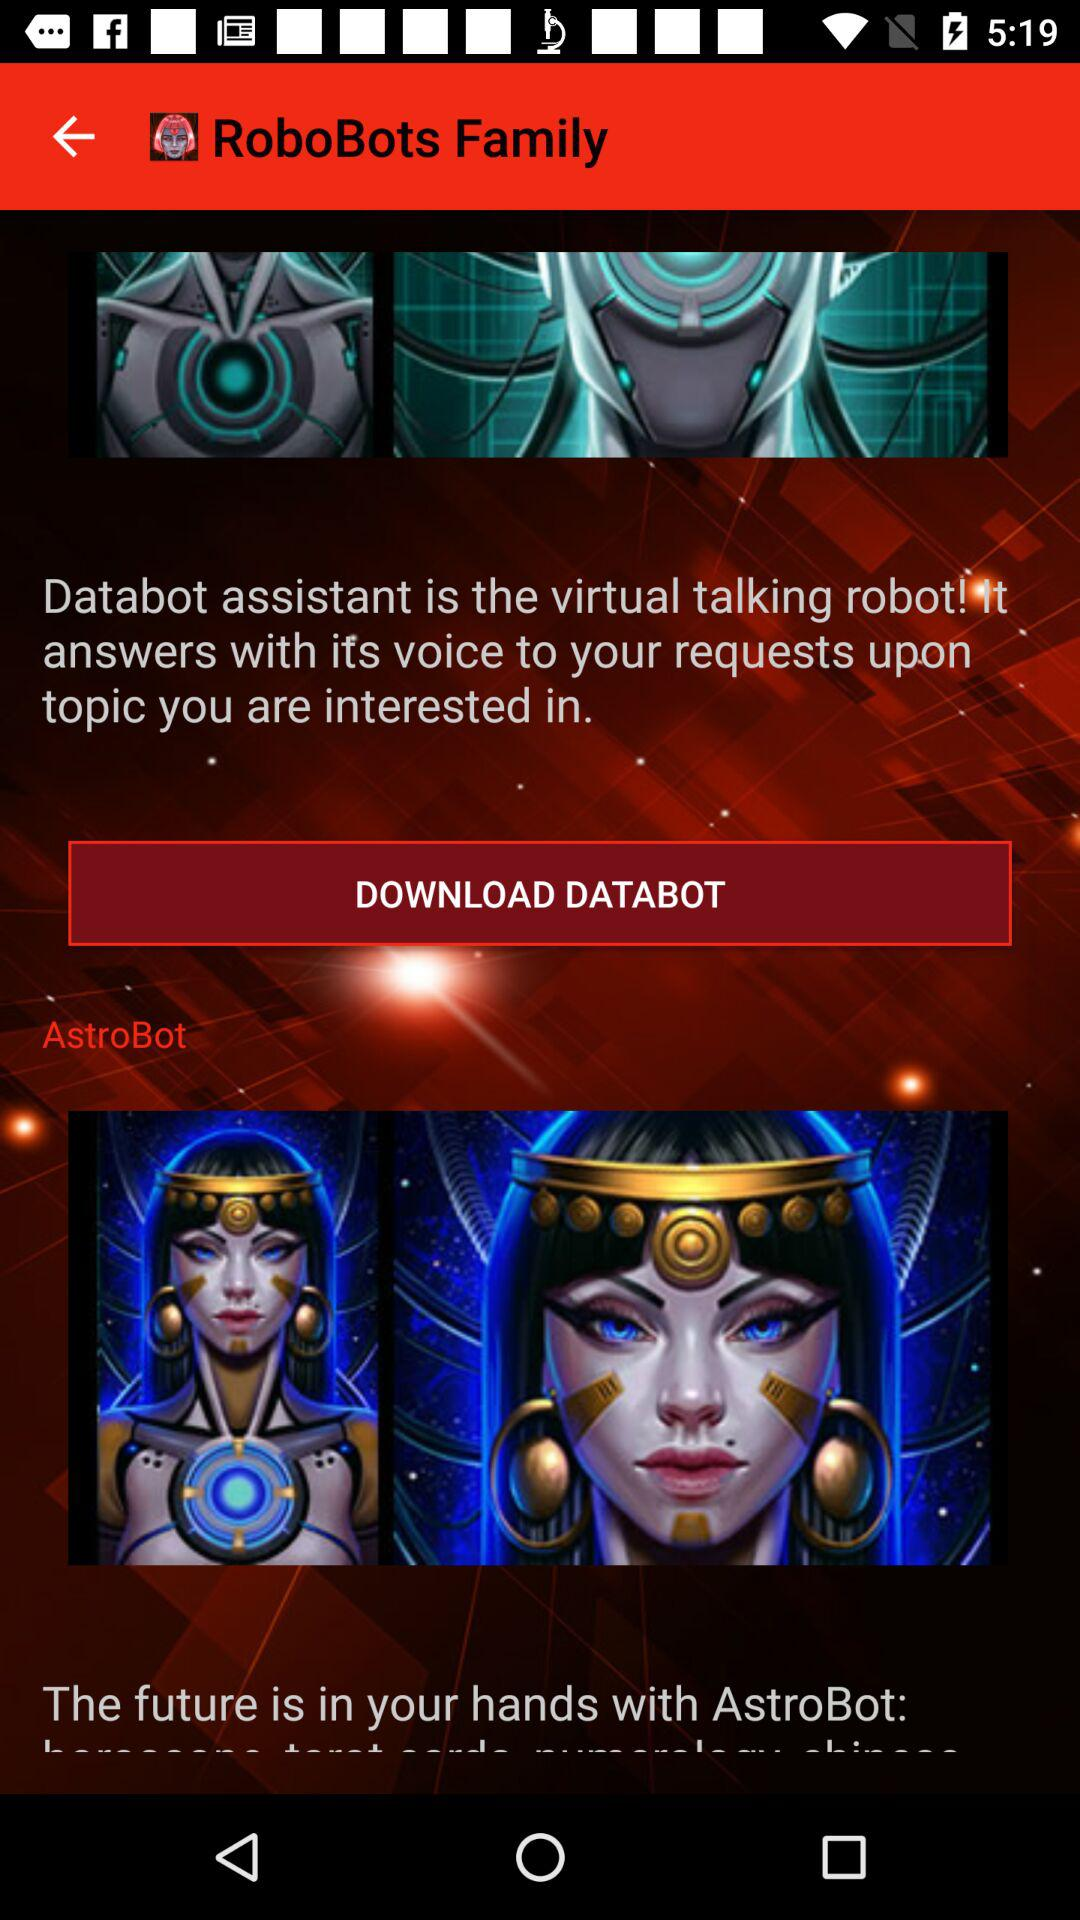What is the application name? The application name is "RoboBots Family". 